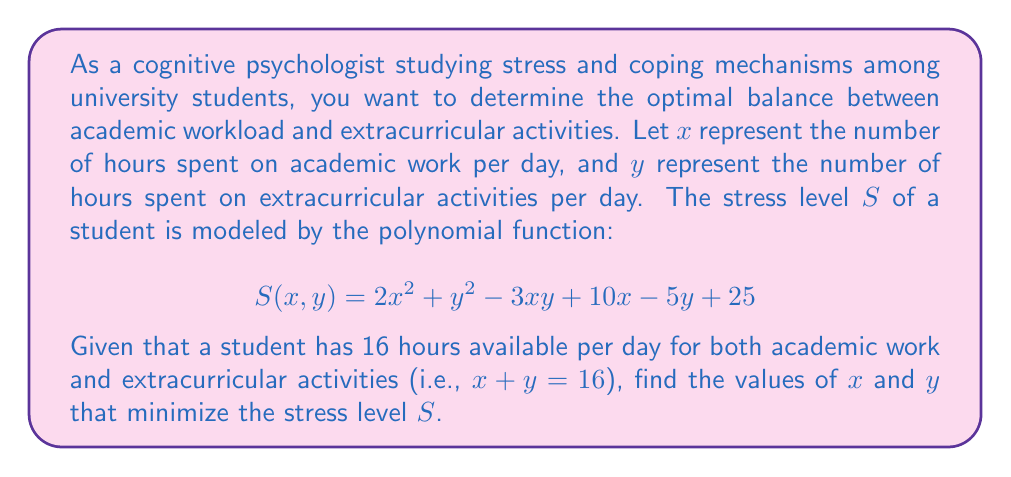Solve this math problem. To solve this optimization problem, we can follow these steps:

1) First, we need to express $y$ in terms of $x$ using the constraint $x + y = 16$:
   $y = 16 - x$

2) Substitute this into the stress function:
   $$S(x) = 2x^2 + (16-x)^2 - 3x(16-x) + 10x - 5(16-x) + 25$$

3) Expand this expression:
   $$S(x) = 2x^2 + 256 - 32x + x^2 - 48x + 3x^2 + 10x - 80 + 5x + 25$$
   $$S(x) = 6x^2 - 65x + 201$$

4) To find the minimum of this quadratic function, we need to find where its derivative equals zero:
   $$\frac{dS}{dx} = 12x - 65$$

5) Set this equal to zero and solve for $x$:
   $$12x - 65 = 0$$
   $$12x = 65$$
   $$x = \frac{65}{12} \approx 5.42$$

6) Since $y = 16 - x$, we can calculate $y$:
   $$y = 16 - 5.42 = 10.58$$

7) To confirm this is a minimum (not a maximum), we can check that the second derivative is positive:
   $$\frac{d^2S}{dx^2} = 12 > 0$$

Therefore, the stress level is minimized when $x \approx 5.42$ and $y \approx 10.58$.
Answer: The optimal balance to minimize stress is approximately 5.42 hours of academic work and 10.58 hours of extracurricular activities per day. 